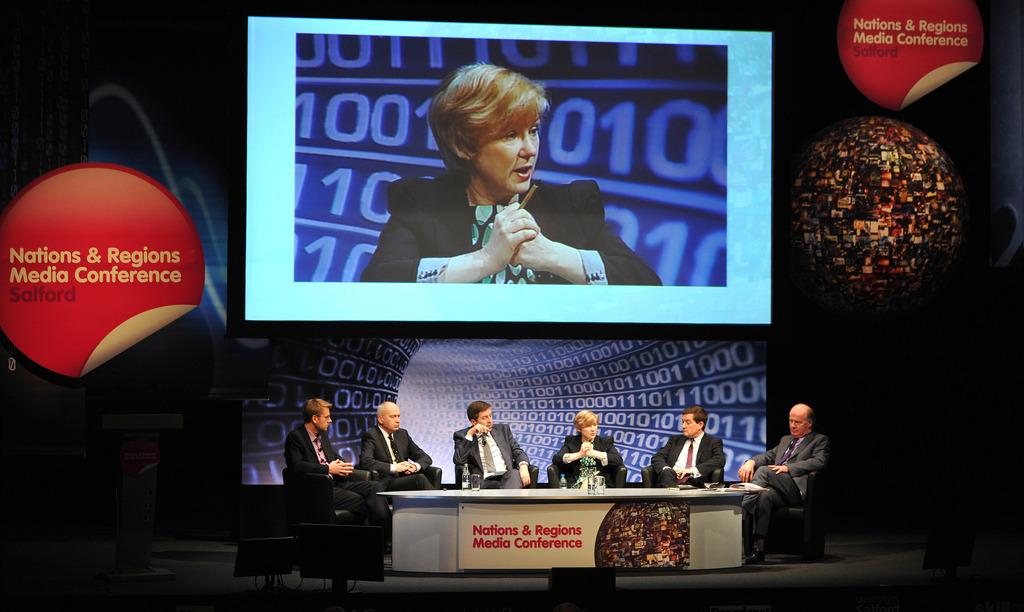What are they talking about on the show?
Give a very brief answer. Nations & regions media conference. Nations & regions what?
Offer a very short reply. Media conference. 